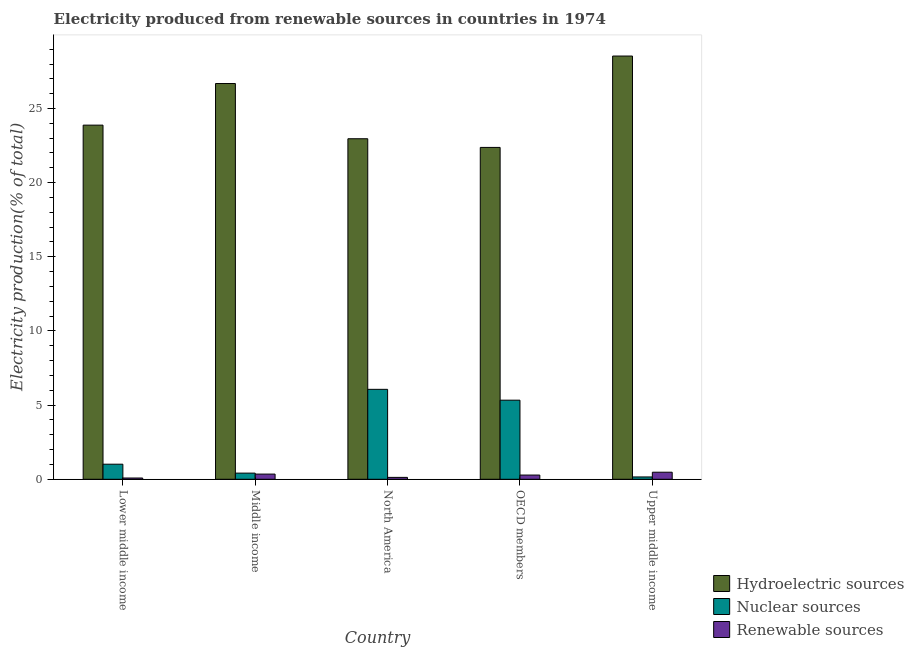How many different coloured bars are there?
Make the answer very short. 3. Are the number of bars per tick equal to the number of legend labels?
Offer a terse response. Yes. How many bars are there on the 5th tick from the left?
Offer a terse response. 3. In how many cases, is the number of bars for a given country not equal to the number of legend labels?
Give a very brief answer. 0. What is the percentage of electricity produced by nuclear sources in Upper middle income?
Give a very brief answer. 0.16. Across all countries, what is the maximum percentage of electricity produced by nuclear sources?
Your answer should be compact. 6.06. Across all countries, what is the minimum percentage of electricity produced by hydroelectric sources?
Provide a short and direct response. 22.38. In which country was the percentage of electricity produced by renewable sources maximum?
Offer a terse response. Upper middle income. What is the total percentage of electricity produced by renewable sources in the graph?
Offer a very short reply. 1.32. What is the difference between the percentage of electricity produced by renewable sources in Middle income and that in North America?
Provide a succinct answer. 0.22. What is the difference between the percentage of electricity produced by nuclear sources in Lower middle income and the percentage of electricity produced by hydroelectric sources in OECD members?
Ensure brevity in your answer.  -21.36. What is the average percentage of electricity produced by nuclear sources per country?
Provide a short and direct response. 2.6. What is the difference between the percentage of electricity produced by renewable sources and percentage of electricity produced by nuclear sources in Upper middle income?
Ensure brevity in your answer.  0.32. In how many countries, is the percentage of electricity produced by nuclear sources greater than 17 %?
Your answer should be compact. 0. What is the ratio of the percentage of electricity produced by hydroelectric sources in Middle income to that in North America?
Your answer should be very brief. 1.16. Is the difference between the percentage of electricity produced by nuclear sources in Lower middle income and Middle income greater than the difference between the percentage of electricity produced by renewable sources in Lower middle income and Middle income?
Keep it short and to the point. Yes. What is the difference between the highest and the second highest percentage of electricity produced by renewable sources?
Offer a terse response. 0.13. What is the difference between the highest and the lowest percentage of electricity produced by nuclear sources?
Offer a very short reply. 5.91. Is the sum of the percentage of electricity produced by hydroelectric sources in Lower middle income and North America greater than the maximum percentage of electricity produced by nuclear sources across all countries?
Provide a succinct answer. Yes. What does the 3rd bar from the left in Upper middle income represents?
Your answer should be very brief. Renewable sources. What does the 3rd bar from the right in North America represents?
Your answer should be very brief. Hydroelectric sources. Is it the case that in every country, the sum of the percentage of electricity produced by hydroelectric sources and percentage of electricity produced by nuclear sources is greater than the percentage of electricity produced by renewable sources?
Ensure brevity in your answer.  Yes. How many bars are there?
Offer a terse response. 15. Are all the bars in the graph horizontal?
Keep it short and to the point. No. How many countries are there in the graph?
Your answer should be very brief. 5. Does the graph contain grids?
Keep it short and to the point. No. Where does the legend appear in the graph?
Provide a succinct answer. Bottom right. How many legend labels are there?
Provide a succinct answer. 3. What is the title of the graph?
Make the answer very short. Electricity produced from renewable sources in countries in 1974. What is the label or title of the Y-axis?
Make the answer very short. Electricity production(% of total). What is the Electricity production(% of total) of Hydroelectric sources in Lower middle income?
Your answer should be very brief. 23.88. What is the Electricity production(% of total) in Nuclear sources in Lower middle income?
Your answer should be compact. 1.02. What is the Electricity production(% of total) in Renewable sources in Lower middle income?
Your response must be concise. 0.09. What is the Electricity production(% of total) of Hydroelectric sources in Middle income?
Your answer should be compact. 26.68. What is the Electricity production(% of total) of Nuclear sources in Middle income?
Your response must be concise. 0.41. What is the Electricity production(% of total) of Renewable sources in Middle income?
Your answer should be very brief. 0.35. What is the Electricity production(% of total) in Hydroelectric sources in North America?
Provide a succinct answer. 22.96. What is the Electricity production(% of total) of Nuclear sources in North America?
Ensure brevity in your answer.  6.06. What is the Electricity production(% of total) in Renewable sources in North America?
Your answer should be very brief. 0.13. What is the Electricity production(% of total) of Hydroelectric sources in OECD members?
Give a very brief answer. 22.38. What is the Electricity production(% of total) of Nuclear sources in OECD members?
Give a very brief answer. 5.33. What is the Electricity production(% of total) of Renewable sources in OECD members?
Your answer should be compact. 0.28. What is the Electricity production(% of total) in Hydroelectric sources in Upper middle income?
Provide a succinct answer. 28.54. What is the Electricity production(% of total) in Nuclear sources in Upper middle income?
Your response must be concise. 0.16. What is the Electricity production(% of total) of Renewable sources in Upper middle income?
Make the answer very short. 0.48. Across all countries, what is the maximum Electricity production(% of total) in Hydroelectric sources?
Provide a short and direct response. 28.54. Across all countries, what is the maximum Electricity production(% of total) in Nuclear sources?
Your answer should be compact. 6.06. Across all countries, what is the maximum Electricity production(% of total) of Renewable sources?
Your response must be concise. 0.48. Across all countries, what is the minimum Electricity production(% of total) in Hydroelectric sources?
Offer a very short reply. 22.38. Across all countries, what is the minimum Electricity production(% of total) of Nuclear sources?
Offer a terse response. 0.16. Across all countries, what is the minimum Electricity production(% of total) in Renewable sources?
Your answer should be compact. 0.09. What is the total Electricity production(% of total) in Hydroelectric sources in the graph?
Ensure brevity in your answer.  124.44. What is the total Electricity production(% of total) of Nuclear sources in the graph?
Give a very brief answer. 12.99. What is the total Electricity production(% of total) in Renewable sources in the graph?
Your response must be concise. 1.32. What is the difference between the Electricity production(% of total) in Hydroelectric sources in Lower middle income and that in Middle income?
Provide a succinct answer. -2.81. What is the difference between the Electricity production(% of total) of Nuclear sources in Lower middle income and that in Middle income?
Offer a very short reply. 0.6. What is the difference between the Electricity production(% of total) in Renewable sources in Lower middle income and that in Middle income?
Offer a terse response. -0.26. What is the difference between the Electricity production(% of total) in Hydroelectric sources in Lower middle income and that in North America?
Give a very brief answer. 0.92. What is the difference between the Electricity production(% of total) in Nuclear sources in Lower middle income and that in North America?
Provide a short and direct response. -5.05. What is the difference between the Electricity production(% of total) in Renewable sources in Lower middle income and that in North America?
Your answer should be very brief. -0.04. What is the difference between the Electricity production(% of total) of Hydroelectric sources in Lower middle income and that in OECD members?
Give a very brief answer. 1.5. What is the difference between the Electricity production(% of total) of Nuclear sources in Lower middle income and that in OECD members?
Your response must be concise. -4.32. What is the difference between the Electricity production(% of total) in Renewable sources in Lower middle income and that in OECD members?
Your answer should be compact. -0.2. What is the difference between the Electricity production(% of total) of Hydroelectric sources in Lower middle income and that in Upper middle income?
Offer a terse response. -4.66. What is the difference between the Electricity production(% of total) in Nuclear sources in Lower middle income and that in Upper middle income?
Provide a succinct answer. 0.86. What is the difference between the Electricity production(% of total) of Renewable sources in Lower middle income and that in Upper middle income?
Offer a terse response. -0.39. What is the difference between the Electricity production(% of total) in Hydroelectric sources in Middle income and that in North America?
Your answer should be very brief. 3.72. What is the difference between the Electricity production(% of total) of Nuclear sources in Middle income and that in North America?
Keep it short and to the point. -5.65. What is the difference between the Electricity production(% of total) of Renewable sources in Middle income and that in North America?
Make the answer very short. 0.22. What is the difference between the Electricity production(% of total) of Hydroelectric sources in Middle income and that in OECD members?
Your answer should be compact. 4.31. What is the difference between the Electricity production(% of total) in Nuclear sources in Middle income and that in OECD members?
Provide a short and direct response. -4.92. What is the difference between the Electricity production(% of total) of Renewable sources in Middle income and that in OECD members?
Provide a succinct answer. 0.07. What is the difference between the Electricity production(% of total) of Hydroelectric sources in Middle income and that in Upper middle income?
Offer a terse response. -1.85. What is the difference between the Electricity production(% of total) in Nuclear sources in Middle income and that in Upper middle income?
Your answer should be very brief. 0.26. What is the difference between the Electricity production(% of total) in Renewable sources in Middle income and that in Upper middle income?
Your answer should be very brief. -0.13. What is the difference between the Electricity production(% of total) of Hydroelectric sources in North America and that in OECD members?
Your response must be concise. 0.59. What is the difference between the Electricity production(% of total) in Nuclear sources in North America and that in OECD members?
Offer a very short reply. 0.73. What is the difference between the Electricity production(% of total) of Renewable sources in North America and that in OECD members?
Ensure brevity in your answer.  -0.16. What is the difference between the Electricity production(% of total) of Hydroelectric sources in North America and that in Upper middle income?
Your response must be concise. -5.58. What is the difference between the Electricity production(% of total) in Nuclear sources in North America and that in Upper middle income?
Your answer should be very brief. 5.91. What is the difference between the Electricity production(% of total) in Renewable sources in North America and that in Upper middle income?
Provide a succinct answer. -0.35. What is the difference between the Electricity production(% of total) in Hydroelectric sources in OECD members and that in Upper middle income?
Your response must be concise. -6.16. What is the difference between the Electricity production(% of total) of Nuclear sources in OECD members and that in Upper middle income?
Make the answer very short. 5.18. What is the difference between the Electricity production(% of total) of Renewable sources in OECD members and that in Upper middle income?
Your answer should be very brief. -0.19. What is the difference between the Electricity production(% of total) of Hydroelectric sources in Lower middle income and the Electricity production(% of total) of Nuclear sources in Middle income?
Keep it short and to the point. 23.46. What is the difference between the Electricity production(% of total) of Hydroelectric sources in Lower middle income and the Electricity production(% of total) of Renewable sources in Middle income?
Ensure brevity in your answer.  23.53. What is the difference between the Electricity production(% of total) in Nuclear sources in Lower middle income and the Electricity production(% of total) in Renewable sources in Middle income?
Your answer should be compact. 0.67. What is the difference between the Electricity production(% of total) of Hydroelectric sources in Lower middle income and the Electricity production(% of total) of Nuclear sources in North America?
Your answer should be compact. 17.81. What is the difference between the Electricity production(% of total) in Hydroelectric sources in Lower middle income and the Electricity production(% of total) in Renewable sources in North America?
Your response must be concise. 23.75. What is the difference between the Electricity production(% of total) in Nuclear sources in Lower middle income and the Electricity production(% of total) in Renewable sources in North America?
Give a very brief answer. 0.89. What is the difference between the Electricity production(% of total) in Hydroelectric sources in Lower middle income and the Electricity production(% of total) in Nuclear sources in OECD members?
Your response must be concise. 18.55. What is the difference between the Electricity production(% of total) in Hydroelectric sources in Lower middle income and the Electricity production(% of total) in Renewable sources in OECD members?
Your answer should be very brief. 23.59. What is the difference between the Electricity production(% of total) in Nuclear sources in Lower middle income and the Electricity production(% of total) in Renewable sources in OECD members?
Your answer should be compact. 0.73. What is the difference between the Electricity production(% of total) of Hydroelectric sources in Lower middle income and the Electricity production(% of total) of Nuclear sources in Upper middle income?
Your response must be concise. 23.72. What is the difference between the Electricity production(% of total) in Hydroelectric sources in Lower middle income and the Electricity production(% of total) in Renewable sources in Upper middle income?
Ensure brevity in your answer.  23.4. What is the difference between the Electricity production(% of total) of Nuclear sources in Lower middle income and the Electricity production(% of total) of Renewable sources in Upper middle income?
Your response must be concise. 0.54. What is the difference between the Electricity production(% of total) of Hydroelectric sources in Middle income and the Electricity production(% of total) of Nuclear sources in North America?
Offer a very short reply. 20.62. What is the difference between the Electricity production(% of total) of Hydroelectric sources in Middle income and the Electricity production(% of total) of Renewable sources in North America?
Ensure brevity in your answer.  26.56. What is the difference between the Electricity production(% of total) in Nuclear sources in Middle income and the Electricity production(% of total) in Renewable sources in North America?
Provide a short and direct response. 0.29. What is the difference between the Electricity production(% of total) in Hydroelectric sources in Middle income and the Electricity production(% of total) in Nuclear sources in OECD members?
Make the answer very short. 21.35. What is the difference between the Electricity production(% of total) of Hydroelectric sources in Middle income and the Electricity production(% of total) of Renewable sources in OECD members?
Your answer should be very brief. 26.4. What is the difference between the Electricity production(% of total) of Nuclear sources in Middle income and the Electricity production(% of total) of Renewable sources in OECD members?
Your response must be concise. 0.13. What is the difference between the Electricity production(% of total) of Hydroelectric sources in Middle income and the Electricity production(% of total) of Nuclear sources in Upper middle income?
Provide a succinct answer. 26.53. What is the difference between the Electricity production(% of total) of Hydroelectric sources in Middle income and the Electricity production(% of total) of Renewable sources in Upper middle income?
Give a very brief answer. 26.21. What is the difference between the Electricity production(% of total) of Nuclear sources in Middle income and the Electricity production(% of total) of Renewable sources in Upper middle income?
Provide a short and direct response. -0.06. What is the difference between the Electricity production(% of total) of Hydroelectric sources in North America and the Electricity production(% of total) of Nuclear sources in OECD members?
Your answer should be very brief. 17.63. What is the difference between the Electricity production(% of total) of Hydroelectric sources in North America and the Electricity production(% of total) of Renewable sources in OECD members?
Provide a succinct answer. 22.68. What is the difference between the Electricity production(% of total) of Nuclear sources in North America and the Electricity production(% of total) of Renewable sources in OECD members?
Your answer should be very brief. 5.78. What is the difference between the Electricity production(% of total) in Hydroelectric sources in North America and the Electricity production(% of total) in Nuclear sources in Upper middle income?
Offer a terse response. 22.8. What is the difference between the Electricity production(% of total) in Hydroelectric sources in North America and the Electricity production(% of total) in Renewable sources in Upper middle income?
Give a very brief answer. 22.49. What is the difference between the Electricity production(% of total) of Nuclear sources in North America and the Electricity production(% of total) of Renewable sources in Upper middle income?
Your answer should be very brief. 5.59. What is the difference between the Electricity production(% of total) in Hydroelectric sources in OECD members and the Electricity production(% of total) in Nuclear sources in Upper middle income?
Offer a terse response. 22.22. What is the difference between the Electricity production(% of total) in Hydroelectric sources in OECD members and the Electricity production(% of total) in Renewable sources in Upper middle income?
Offer a terse response. 21.9. What is the difference between the Electricity production(% of total) in Nuclear sources in OECD members and the Electricity production(% of total) in Renewable sources in Upper middle income?
Offer a very short reply. 4.86. What is the average Electricity production(% of total) in Hydroelectric sources per country?
Ensure brevity in your answer.  24.89. What is the average Electricity production(% of total) in Nuclear sources per country?
Keep it short and to the point. 2.6. What is the average Electricity production(% of total) of Renewable sources per country?
Your answer should be compact. 0.26. What is the difference between the Electricity production(% of total) of Hydroelectric sources and Electricity production(% of total) of Nuclear sources in Lower middle income?
Make the answer very short. 22.86. What is the difference between the Electricity production(% of total) in Hydroelectric sources and Electricity production(% of total) in Renewable sources in Lower middle income?
Provide a succinct answer. 23.79. What is the difference between the Electricity production(% of total) of Nuclear sources and Electricity production(% of total) of Renewable sources in Lower middle income?
Your answer should be very brief. 0.93. What is the difference between the Electricity production(% of total) in Hydroelectric sources and Electricity production(% of total) in Nuclear sources in Middle income?
Offer a terse response. 26.27. What is the difference between the Electricity production(% of total) of Hydroelectric sources and Electricity production(% of total) of Renewable sources in Middle income?
Provide a succinct answer. 26.33. What is the difference between the Electricity production(% of total) of Nuclear sources and Electricity production(% of total) of Renewable sources in Middle income?
Give a very brief answer. 0.06. What is the difference between the Electricity production(% of total) of Hydroelectric sources and Electricity production(% of total) of Nuclear sources in North America?
Provide a short and direct response. 16.9. What is the difference between the Electricity production(% of total) of Hydroelectric sources and Electricity production(% of total) of Renewable sources in North America?
Your answer should be very brief. 22.83. What is the difference between the Electricity production(% of total) of Nuclear sources and Electricity production(% of total) of Renewable sources in North America?
Provide a succinct answer. 5.94. What is the difference between the Electricity production(% of total) in Hydroelectric sources and Electricity production(% of total) in Nuclear sources in OECD members?
Provide a succinct answer. 17.04. What is the difference between the Electricity production(% of total) of Hydroelectric sources and Electricity production(% of total) of Renewable sources in OECD members?
Your response must be concise. 22.09. What is the difference between the Electricity production(% of total) in Nuclear sources and Electricity production(% of total) in Renewable sources in OECD members?
Your answer should be very brief. 5.05. What is the difference between the Electricity production(% of total) of Hydroelectric sources and Electricity production(% of total) of Nuclear sources in Upper middle income?
Ensure brevity in your answer.  28.38. What is the difference between the Electricity production(% of total) in Hydroelectric sources and Electricity production(% of total) in Renewable sources in Upper middle income?
Keep it short and to the point. 28.06. What is the difference between the Electricity production(% of total) in Nuclear sources and Electricity production(% of total) in Renewable sources in Upper middle income?
Make the answer very short. -0.32. What is the ratio of the Electricity production(% of total) of Hydroelectric sources in Lower middle income to that in Middle income?
Your answer should be very brief. 0.89. What is the ratio of the Electricity production(% of total) of Nuclear sources in Lower middle income to that in Middle income?
Provide a short and direct response. 2.45. What is the ratio of the Electricity production(% of total) of Renewable sources in Lower middle income to that in Middle income?
Your response must be concise. 0.24. What is the ratio of the Electricity production(% of total) in Nuclear sources in Lower middle income to that in North America?
Make the answer very short. 0.17. What is the ratio of the Electricity production(% of total) of Renewable sources in Lower middle income to that in North America?
Your response must be concise. 0.67. What is the ratio of the Electricity production(% of total) of Hydroelectric sources in Lower middle income to that in OECD members?
Your response must be concise. 1.07. What is the ratio of the Electricity production(% of total) in Nuclear sources in Lower middle income to that in OECD members?
Your answer should be compact. 0.19. What is the ratio of the Electricity production(% of total) of Renewable sources in Lower middle income to that in OECD members?
Provide a short and direct response. 0.3. What is the ratio of the Electricity production(% of total) of Hydroelectric sources in Lower middle income to that in Upper middle income?
Provide a succinct answer. 0.84. What is the ratio of the Electricity production(% of total) in Nuclear sources in Lower middle income to that in Upper middle income?
Your answer should be compact. 6.46. What is the ratio of the Electricity production(% of total) in Renewable sources in Lower middle income to that in Upper middle income?
Offer a terse response. 0.18. What is the ratio of the Electricity production(% of total) in Hydroelectric sources in Middle income to that in North America?
Offer a terse response. 1.16. What is the ratio of the Electricity production(% of total) in Nuclear sources in Middle income to that in North America?
Make the answer very short. 0.07. What is the ratio of the Electricity production(% of total) in Renewable sources in Middle income to that in North America?
Provide a short and direct response. 2.74. What is the ratio of the Electricity production(% of total) of Hydroelectric sources in Middle income to that in OECD members?
Your answer should be very brief. 1.19. What is the ratio of the Electricity production(% of total) of Nuclear sources in Middle income to that in OECD members?
Give a very brief answer. 0.08. What is the ratio of the Electricity production(% of total) in Renewable sources in Middle income to that in OECD members?
Give a very brief answer. 1.23. What is the ratio of the Electricity production(% of total) in Hydroelectric sources in Middle income to that in Upper middle income?
Your response must be concise. 0.94. What is the ratio of the Electricity production(% of total) of Nuclear sources in Middle income to that in Upper middle income?
Give a very brief answer. 2.64. What is the ratio of the Electricity production(% of total) in Renewable sources in Middle income to that in Upper middle income?
Your response must be concise. 0.74. What is the ratio of the Electricity production(% of total) in Hydroelectric sources in North America to that in OECD members?
Give a very brief answer. 1.03. What is the ratio of the Electricity production(% of total) of Nuclear sources in North America to that in OECD members?
Ensure brevity in your answer.  1.14. What is the ratio of the Electricity production(% of total) in Renewable sources in North America to that in OECD members?
Give a very brief answer. 0.45. What is the ratio of the Electricity production(% of total) of Hydroelectric sources in North America to that in Upper middle income?
Your response must be concise. 0.8. What is the ratio of the Electricity production(% of total) in Nuclear sources in North America to that in Upper middle income?
Your response must be concise. 38.57. What is the ratio of the Electricity production(% of total) in Renewable sources in North America to that in Upper middle income?
Your answer should be very brief. 0.27. What is the ratio of the Electricity production(% of total) in Hydroelectric sources in OECD members to that in Upper middle income?
Make the answer very short. 0.78. What is the ratio of the Electricity production(% of total) of Nuclear sources in OECD members to that in Upper middle income?
Ensure brevity in your answer.  33.92. What is the ratio of the Electricity production(% of total) in Renewable sources in OECD members to that in Upper middle income?
Ensure brevity in your answer.  0.6. What is the difference between the highest and the second highest Electricity production(% of total) of Hydroelectric sources?
Provide a short and direct response. 1.85. What is the difference between the highest and the second highest Electricity production(% of total) of Nuclear sources?
Your response must be concise. 0.73. What is the difference between the highest and the second highest Electricity production(% of total) of Renewable sources?
Provide a short and direct response. 0.13. What is the difference between the highest and the lowest Electricity production(% of total) of Hydroelectric sources?
Make the answer very short. 6.16. What is the difference between the highest and the lowest Electricity production(% of total) of Nuclear sources?
Keep it short and to the point. 5.91. What is the difference between the highest and the lowest Electricity production(% of total) in Renewable sources?
Keep it short and to the point. 0.39. 